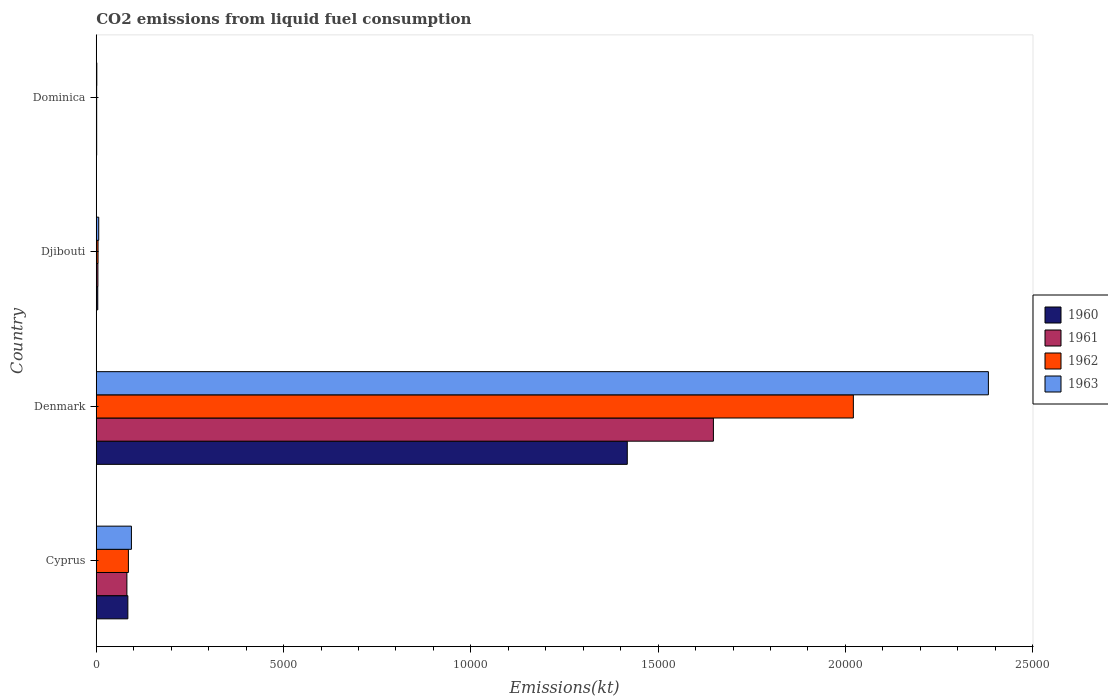How many different coloured bars are there?
Ensure brevity in your answer.  4. How many groups of bars are there?
Keep it short and to the point. 4. Are the number of bars per tick equal to the number of legend labels?
Your answer should be very brief. Yes. How many bars are there on the 3rd tick from the top?
Provide a succinct answer. 4. How many bars are there on the 4th tick from the bottom?
Your answer should be compact. 4. What is the label of the 1st group of bars from the top?
Your answer should be very brief. Dominica. In how many cases, is the number of bars for a given country not equal to the number of legend labels?
Ensure brevity in your answer.  0. What is the amount of CO2 emitted in 1963 in Denmark?
Give a very brief answer. 2.38e+04. Across all countries, what is the maximum amount of CO2 emitted in 1961?
Ensure brevity in your answer.  1.65e+04. Across all countries, what is the minimum amount of CO2 emitted in 1961?
Provide a succinct answer. 11. In which country was the amount of CO2 emitted in 1962 minimum?
Offer a very short reply. Dominica. What is the total amount of CO2 emitted in 1962 in the graph?
Provide a short and direct response. 2.11e+04. What is the difference between the amount of CO2 emitted in 1961 in Denmark and that in Djibouti?
Ensure brevity in your answer.  1.64e+04. What is the difference between the amount of CO2 emitted in 1961 in Cyprus and the amount of CO2 emitted in 1960 in Denmark?
Your response must be concise. -1.34e+04. What is the average amount of CO2 emitted in 1962 per country?
Offer a terse response. 5282.31. What is the difference between the amount of CO2 emitted in 1963 and amount of CO2 emitted in 1962 in Denmark?
Offer a terse response. 3604.66. What is the ratio of the amount of CO2 emitted in 1962 in Denmark to that in Djibouti?
Provide a succinct answer. 424. What is the difference between the highest and the second highest amount of CO2 emitted in 1960?
Your response must be concise. 1.33e+04. What is the difference between the highest and the lowest amount of CO2 emitted in 1963?
Offer a very short reply. 2.38e+04. In how many countries, is the amount of CO2 emitted in 1961 greater than the average amount of CO2 emitted in 1961 taken over all countries?
Your response must be concise. 1. Is the sum of the amount of CO2 emitted in 1962 in Djibouti and Dominica greater than the maximum amount of CO2 emitted in 1963 across all countries?
Your answer should be compact. No. Is it the case that in every country, the sum of the amount of CO2 emitted in 1960 and amount of CO2 emitted in 1962 is greater than the sum of amount of CO2 emitted in 1961 and amount of CO2 emitted in 1963?
Your answer should be very brief. No. What does the 3rd bar from the top in Cyprus represents?
Provide a succinct answer. 1961. Is it the case that in every country, the sum of the amount of CO2 emitted in 1962 and amount of CO2 emitted in 1961 is greater than the amount of CO2 emitted in 1963?
Your response must be concise. Yes. Are all the bars in the graph horizontal?
Give a very brief answer. Yes. How many countries are there in the graph?
Provide a succinct answer. 4. Are the values on the major ticks of X-axis written in scientific E-notation?
Offer a very short reply. No. Does the graph contain any zero values?
Ensure brevity in your answer.  No. Does the graph contain grids?
Provide a short and direct response. No. How many legend labels are there?
Keep it short and to the point. 4. What is the title of the graph?
Offer a terse response. CO2 emissions from liquid fuel consumption. What is the label or title of the X-axis?
Keep it short and to the point. Emissions(kt). What is the Emissions(kt) in 1960 in Cyprus?
Provide a short and direct response. 843.41. What is the Emissions(kt) of 1961 in Cyprus?
Offer a very short reply. 817.74. What is the Emissions(kt) of 1962 in Cyprus?
Offer a terse response. 858.08. What is the Emissions(kt) in 1963 in Cyprus?
Give a very brief answer. 938.75. What is the Emissions(kt) in 1960 in Denmark?
Provide a short and direct response. 1.42e+04. What is the Emissions(kt) of 1961 in Denmark?
Offer a very short reply. 1.65e+04. What is the Emissions(kt) of 1962 in Denmark?
Offer a very short reply. 2.02e+04. What is the Emissions(kt) of 1963 in Denmark?
Keep it short and to the point. 2.38e+04. What is the Emissions(kt) of 1960 in Djibouti?
Your response must be concise. 40.34. What is the Emissions(kt) in 1961 in Djibouti?
Make the answer very short. 44. What is the Emissions(kt) of 1962 in Djibouti?
Ensure brevity in your answer.  47.67. What is the Emissions(kt) of 1963 in Djibouti?
Provide a short and direct response. 66.01. What is the Emissions(kt) of 1960 in Dominica?
Provide a succinct answer. 11. What is the Emissions(kt) in 1961 in Dominica?
Make the answer very short. 11. What is the Emissions(kt) of 1962 in Dominica?
Offer a terse response. 11. What is the Emissions(kt) in 1963 in Dominica?
Provide a short and direct response. 14.67. Across all countries, what is the maximum Emissions(kt) of 1960?
Make the answer very short. 1.42e+04. Across all countries, what is the maximum Emissions(kt) of 1961?
Provide a succinct answer. 1.65e+04. Across all countries, what is the maximum Emissions(kt) in 1962?
Your answer should be very brief. 2.02e+04. Across all countries, what is the maximum Emissions(kt) in 1963?
Your answer should be compact. 2.38e+04. Across all countries, what is the minimum Emissions(kt) of 1960?
Provide a succinct answer. 11. Across all countries, what is the minimum Emissions(kt) in 1961?
Offer a terse response. 11. Across all countries, what is the minimum Emissions(kt) in 1962?
Offer a terse response. 11. Across all countries, what is the minimum Emissions(kt) of 1963?
Offer a very short reply. 14.67. What is the total Emissions(kt) of 1960 in the graph?
Offer a terse response. 1.51e+04. What is the total Emissions(kt) in 1961 in the graph?
Offer a very short reply. 1.73e+04. What is the total Emissions(kt) of 1962 in the graph?
Provide a short and direct response. 2.11e+04. What is the total Emissions(kt) in 1963 in the graph?
Give a very brief answer. 2.48e+04. What is the difference between the Emissions(kt) of 1960 in Cyprus and that in Denmark?
Your answer should be compact. -1.33e+04. What is the difference between the Emissions(kt) in 1961 in Cyprus and that in Denmark?
Provide a succinct answer. -1.57e+04. What is the difference between the Emissions(kt) of 1962 in Cyprus and that in Denmark?
Offer a terse response. -1.94e+04. What is the difference between the Emissions(kt) of 1963 in Cyprus and that in Denmark?
Keep it short and to the point. -2.29e+04. What is the difference between the Emissions(kt) of 1960 in Cyprus and that in Djibouti?
Keep it short and to the point. 803.07. What is the difference between the Emissions(kt) in 1961 in Cyprus and that in Djibouti?
Provide a succinct answer. 773.74. What is the difference between the Emissions(kt) of 1962 in Cyprus and that in Djibouti?
Your response must be concise. 810.41. What is the difference between the Emissions(kt) in 1963 in Cyprus and that in Djibouti?
Give a very brief answer. 872.75. What is the difference between the Emissions(kt) in 1960 in Cyprus and that in Dominica?
Ensure brevity in your answer.  832.41. What is the difference between the Emissions(kt) in 1961 in Cyprus and that in Dominica?
Provide a short and direct response. 806.74. What is the difference between the Emissions(kt) of 1962 in Cyprus and that in Dominica?
Your answer should be compact. 847.08. What is the difference between the Emissions(kt) in 1963 in Cyprus and that in Dominica?
Your response must be concise. 924.08. What is the difference between the Emissions(kt) of 1960 in Denmark and that in Djibouti?
Offer a very short reply. 1.41e+04. What is the difference between the Emissions(kt) of 1961 in Denmark and that in Djibouti?
Offer a terse response. 1.64e+04. What is the difference between the Emissions(kt) in 1962 in Denmark and that in Djibouti?
Ensure brevity in your answer.  2.02e+04. What is the difference between the Emissions(kt) of 1963 in Denmark and that in Djibouti?
Provide a succinct answer. 2.38e+04. What is the difference between the Emissions(kt) in 1960 in Denmark and that in Dominica?
Provide a succinct answer. 1.42e+04. What is the difference between the Emissions(kt) in 1961 in Denmark and that in Dominica?
Your answer should be compact. 1.65e+04. What is the difference between the Emissions(kt) in 1962 in Denmark and that in Dominica?
Your answer should be compact. 2.02e+04. What is the difference between the Emissions(kt) of 1963 in Denmark and that in Dominica?
Your answer should be compact. 2.38e+04. What is the difference between the Emissions(kt) of 1960 in Djibouti and that in Dominica?
Offer a very short reply. 29.34. What is the difference between the Emissions(kt) of 1961 in Djibouti and that in Dominica?
Offer a very short reply. 33. What is the difference between the Emissions(kt) in 1962 in Djibouti and that in Dominica?
Your answer should be compact. 36.67. What is the difference between the Emissions(kt) in 1963 in Djibouti and that in Dominica?
Your answer should be very brief. 51.34. What is the difference between the Emissions(kt) of 1960 in Cyprus and the Emissions(kt) of 1961 in Denmark?
Give a very brief answer. -1.56e+04. What is the difference between the Emissions(kt) of 1960 in Cyprus and the Emissions(kt) of 1962 in Denmark?
Your response must be concise. -1.94e+04. What is the difference between the Emissions(kt) of 1960 in Cyprus and the Emissions(kt) of 1963 in Denmark?
Provide a short and direct response. -2.30e+04. What is the difference between the Emissions(kt) in 1961 in Cyprus and the Emissions(kt) in 1962 in Denmark?
Offer a terse response. -1.94e+04. What is the difference between the Emissions(kt) in 1961 in Cyprus and the Emissions(kt) in 1963 in Denmark?
Give a very brief answer. -2.30e+04. What is the difference between the Emissions(kt) of 1962 in Cyprus and the Emissions(kt) of 1963 in Denmark?
Provide a short and direct response. -2.30e+04. What is the difference between the Emissions(kt) of 1960 in Cyprus and the Emissions(kt) of 1961 in Djibouti?
Offer a terse response. 799.41. What is the difference between the Emissions(kt) in 1960 in Cyprus and the Emissions(kt) in 1962 in Djibouti?
Provide a short and direct response. 795.74. What is the difference between the Emissions(kt) of 1960 in Cyprus and the Emissions(kt) of 1963 in Djibouti?
Offer a terse response. 777.4. What is the difference between the Emissions(kt) in 1961 in Cyprus and the Emissions(kt) in 1962 in Djibouti?
Your response must be concise. 770.07. What is the difference between the Emissions(kt) in 1961 in Cyprus and the Emissions(kt) in 1963 in Djibouti?
Offer a very short reply. 751.74. What is the difference between the Emissions(kt) of 1962 in Cyprus and the Emissions(kt) of 1963 in Djibouti?
Your answer should be compact. 792.07. What is the difference between the Emissions(kt) of 1960 in Cyprus and the Emissions(kt) of 1961 in Dominica?
Your response must be concise. 832.41. What is the difference between the Emissions(kt) of 1960 in Cyprus and the Emissions(kt) of 1962 in Dominica?
Provide a short and direct response. 832.41. What is the difference between the Emissions(kt) of 1960 in Cyprus and the Emissions(kt) of 1963 in Dominica?
Keep it short and to the point. 828.74. What is the difference between the Emissions(kt) of 1961 in Cyprus and the Emissions(kt) of 1962 in Dominica?
Keep it short and to the point. 806.74. What is the difference between the Emissions(kt) of 1961 in Cyprus and the Emissions(kt) of 1963 in Dominica?
Your answer should be compact. 803.07. What is the difference between the Emissions(kt) of 1962 in Cyprus and the Emissions(kt) of 1963 in Dominica?
Keep it short and to the point. 843.41. What is the difference between the Emissions(kt) of 1960 in Denmark and the Emissions(kt) of 1961 in Djibouti?
Ensure brevity in your answer.  1.41e+04. What is the difference between the Emissions(kt) of 1960 in Denmark and the Emissions(kt) of 1962 in Djibouti?
Provide a succinct answer. 1.41e+04. What is the difference between the Emissions(kt) of 1960 in Denmark and the Emissions(kt) of 1963 in Djibouti?
Give a very brief answer. 1.41e+04. What is the difference between the Emissions(kt) of 1961 in Denmark and the Emissions(kt) of 1962 in Djibouti?
Make the answer very short. 1.64e+04. What is the difference between the Emissions(kt) of 1961 in Denmark and the Emissions(kt) of 1963 in Djibouti?
Keep it short and to the point. 1.64e+04. What is the difference between the Emissions(kt) in 1962 in Denmark and the Emissions(kt) in 1963 in Djibouti?
Give a very brief answer. 2.01e+04. What is the difference between the Emissions(kt) of 1960 in Denmark and the Emissions(kt) of 1961 in Dominica?
Ensure brevity in your answer.  1.42e+04. What is the difference between the Emissions(kt) of 1960 in Denmark and the Emissions(kt) of 1962 in Dominica?
Ensure brevity in your answer.  1.42e+04. What is the difference between the Emissions(kt) of 1960 in Denmark and the Emissions(kt) of 1963 in Dominica?
Offer a very short reply. 1.42e+04. What is the difference between the Emissions(kt) of 1961 in Denmark and the Emissions(kt) of 1962 in Dominica?
Your answer should be very brief. 1.65e+04. What is the difference between the Emissions(kt) of 1961 in Denmark and the Emissions(kt) of 1963 in Dominica?
Offer a very short reply. 1.65e+04. What is the difference between the Emissions(kt) of 1962 in Denmark and the Emissions(kt) of 1963 in Dominica?
Offer a very short reply. 2.02e+04. What is the difference between the Emissions(kt) in 1960 in Djibouti and the Emissions(kt) in 1961 in Dominica?
Your response must be concise. 29.34. What is the difference between the Emissions(kt) in 1960 in Djibouti and the Emissions(kt) in 1962 in Dominica?
Keep it short and to the point. 29.34. What is the difference between the Emissions(kt) of 1960 in Djibouti and the Emissions(kt) of 1963 in Dominica?
Keep it short and to the point. 25.67. What is the difference between the Emissions(kt) in 1961 in Djibouti and the Emissions(kt) in 1962 in Dominica?
Your answer should be compact. 33. What is the difference between the Emissions(kt) of 1961 in Djibouti and the Emissions(kt) of 1963 in Dominica?
Your answer should be very brief. 29.34. What is the difference between the Emissions(kt) of 1962 in Djibouti and the Emissions(kt) of 1963 in Dominica?
Your response must be concise. 33. What is the average Emissions(kt) of 1960 per country?
Provide a short and direct response. 3767.84. What is the average Emissions(kt) in 1961 per country?
Your response must be concise. 4337.14. What is the average Emissions(kt) in 1962 per country?
Provide a succinct answer. 5282.31. What is the average Emissions(kt) of 1963 per country?
Your response must be concise. 6209.15. What is the difference between the Emissions(kt) in 1960 and Emissions(kt) in 1961 in Cyprus?
Ensure brevity in your answer.  25.67. What is the difference between the Emissions(kt) of 1960 and Emissions(kt) of 1962 in Cyprus?
Make the answer very short. -14.67. What is the difference between the Emissions(kt) of 1960 and Emissions(kt) of 1963 in Cyprus?
Keep it short and to the point. -95.34. What is the difference between the Emissions(kt) in 1961 and Emissions(kt) in 1962 in Cyprus?
Your answer should be compact. -40.34. What is the difference between the Emissions(kt) of 1961 and Emissions(kt) of 1963 in Cyprus?
Provide a short and direct response. -121.01. What is the difference between the Emissions(kt) in 1962 and Emissions(kt) in 1963 in Cyprus?
Offer a very short reply. -80.67. What is the difference between the Emissions(kt) in 1960 and Emissions(kt) in 1961 in Denmark?
Your answer should be very brief. -2299.21. What is the difference between the Emissions(kt) of 1960 and Emissions(kt) of 1962 in Denmark?
Make the answer very short. -6035.88. What is the difference between the Emissions(kt) in 1960 and Emissions(kt) in 1963 in Denmark?
Provide a short and direct response. -9640.54. What is the difference between the Emissions(kt) of 1961 and Emissions(kt) of 1962 in Denmark?
Provide a succinct answer. -3736.67. What is the difference between the Emissions(kt) in 1961 and Emissions(kt) in 1963 in Denmark?
Make the answer very short. -7341.33. What is the difference between the Emissions(kt) of 1962 and Emissions(kt) of 1963 in Denmark?
Provide a short and direct response. -3604.66. What is the difference between the Emissions(kt) in 1960 and Emissions(kt) in 1961 in Djibouti?
Give a very brief answer. -3.67. What is the difference between the Emissions(kt) of 1960 and Emissions(kt) of 1962 in Djibouti?
Your answer should be very brief. -7.33. What is the difference between the Emissions(kt) of 1960 and Emissions(kt) of 1963 in Djibouti?
Provide a short and direct response. -25.67. What is the difference between the Emissions(kt) of 1961 and Emissions(kt) of 1962 in Djibouti?
Provide a short and direct response. -3.67. What is the difference between the Emissions(kt) of 1961 and Emissions(kt) of 1963 in Djibouti?
Your answer should be very brief. -22. What is the difference between the Emissions(kt) of 1962 and Emissions(kt) of 1963 in Djibouti?
Provide a short and direct response. -18.34. What is the difference between the Emissions(kt) of 1960 and Emissions(kt) of 1962 in Dominica?
Offer a terse response. 0. What is the difference between the Emissions(kt) in 1960 and Emissions(kt) in 1963 in Dominica?
Provide a short and direct response. -3.67. What is the difference between the Emissions(kt) in 1961 and Emissions(kt) in 1963 in Dominica?
Your answer should be very brief. -3.67. What is the difference between the Emissions(kt) in 1962 and Emissions(kt) in 1963 in Dominica?
Make the answer very short. -3.67. What is the ratio of the Emissions(kt) of 1960 in Cyprus to that in Denmark?
Provide a short and direct response. 0.06. What is the ratio of the Emissions(kt) of 1961 in Cyprus to that in Denmark?
Your answer should be very brief. 0.05. What is the ratio of the Emissions(kt) of 1962 in Cyprus to that in Denmark?
Offer a very short reply. 0.04. What is the ratio of the Emissions(kt) in 1963 in Cyprus to that in Denmark?
Ensure brevity in your answer.  0.04. What is the ratio of the Emissions(kt) in 1960 in Cyprus to that in Djibouti?
Offer a very short reply. 20.91. What is the ratio of the Emissions(kt) of 1961 in Cyprus to that in Djibouti?
Offer a terse response. 18.58. What is the ratio of the Emissions(kt) in 1962 in Cyprus to that in Djibouti?
Give a very brief answer. 18. What is the ratio of the Emissions(kt) of 1963 in Cyprus to that in Djibouti?
Offer a very short reply. 14.22. What is the ratio of the Emissions(kt) in 1960 in Cyprus to that in Dominica?
Provide a succinct answer. 76.67. What is the ratio of the Emissions(kt) of 1961 in Cyprus to that in Dominica?
Provide a short and direct response. 74.33. What is the ratio of the Emissions(kt) in 1960 in Denmark to that in Djibouti?
Your answer should be compact. 351.45. What is the ratio of the Emissions(kt) of 1961 in Denmark to that in Djibouti?
Offer a very short reply. 374.42. What is the ratio of the Emissions(kt) of 1962 in Denmark to that in Djibouti?
Keep it short and to the point. 424. What is the ratio of the Emissions(kt) of 1963 in Denmark to that in Djibouti?
Offer a very short reply. 360.83. What is the ratio of the Emissions(kt) of 1960 in Denmark to that in Dominica?
Offer a very short reply. 1288.67. What is the ratio of the Emissions(kt) of 1961 in Denmark to that in Dominica?
Provide a short and direct response. 1497.67. What is the ratio of the Emissions(kt) in 1962 in Denmark to that in Dominica?
Offer a terse response. 1837.33. What is the ratio of the Emissions(kt) of 1963 in Denmark to that in Dominica?
Make the answer very short. 1623.75. What is the ratio of the Emissions(kt) in 1960 in Djibouti to that in Dominica?
Give a very brief answer. 3.67. What is the ratio of the Emissions(kt) of 1961 in Djibouti to that in Dominica?
Offer a terse response. 4. What is the ratio of the Emissions(kt) of 1962 in Djibouti to that in Dominica?
Make the answer very short. 4.33. What is the ratio of the Emissions(kt) of 1963 in Djibouti to that in Dominica?
Provide a succinct answer. 4.5. What is the difference between the highest and the second highest Emissions(kt) in 1960?
Provide a succinct answer. 1.33e+04. What is the difference between the highest and the second highest Emissions(kt) in 1961?
Provide a short and direct response. 1.57e+04. What is the difference between the highest and the second highest Emissions(kt) of 1962?
Your answer should be compact. 1.94e+04. What is the difference between the highest and the second highest Emissions(kt) in 1963?
Provide a short and direct response. 2.29e+04. What is the difference between the highest and the lowest Emissions(kt) in 1960?
Keep it short and to the point. 1.42e+04. What is the difference between the highest and the lowest Emissions(kt) in 1961?
Give a very brief answer. 1.65e+04. What is the difference between the highest and the lowest Emissions(kt) in 1962?
Offer a very short reply. 2.02e+04. What is the difference between the highest and the lowest Emissions(kt) in 1963?
Give a very brief answer. 2.38e+04. 